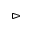Convert formula to latex. <formula><loc_0><loc_0><loc_500><loc_500>\vartriangleright</formula> 